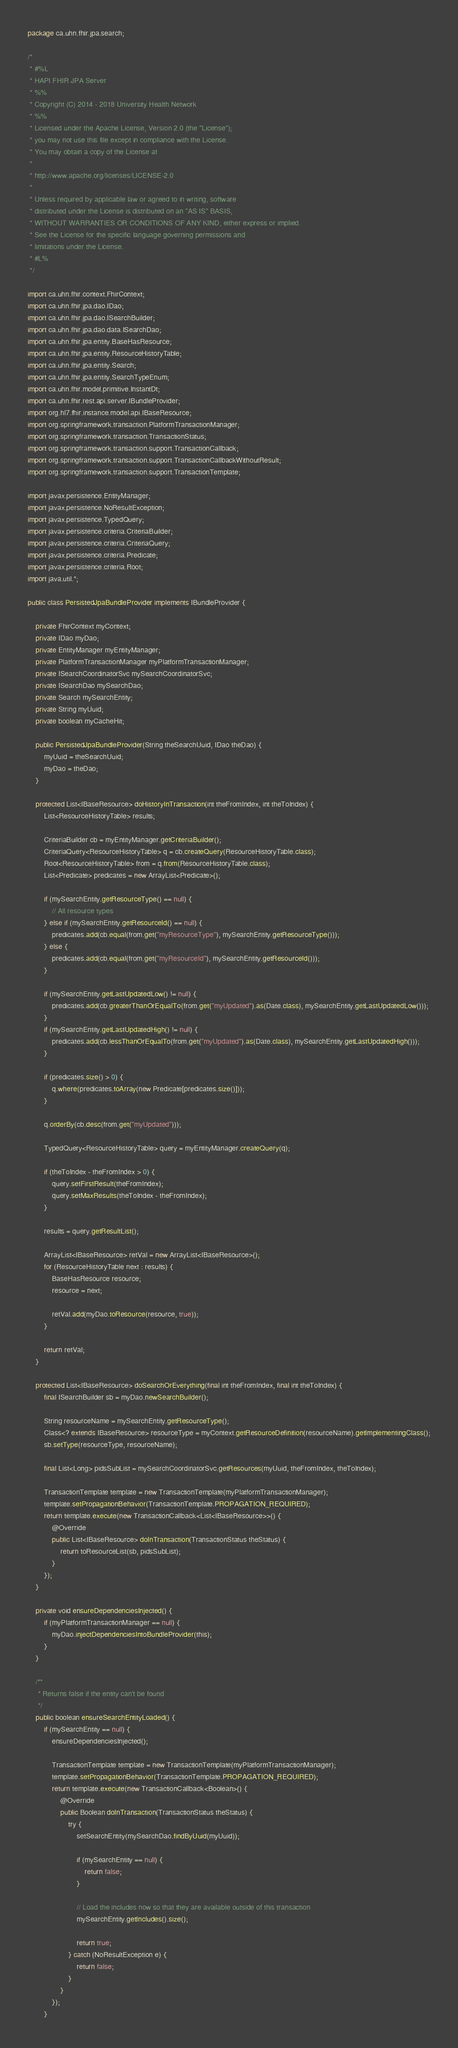Convert code to text. <code><loc_0><loc_0><loc_500><loc_500><_Java_>package ca.uhn.fhir.jpa.search;

/*
 * #%L
 * HAPI FHIR JPA Server
 * %%
 * Copyright (C) 2014 - 2018 University Health Network
 * %%
 * Licensed under the Apache License, Version 2.0 (the "License");
 * you may not use this file except in compliance with the License.
 * You may obtain a copy of the License at
 * 
 * http://www.apache.org/licenses/LICENSE-2.0
 * 
 * Unless required by applicable law or agreed to in writing, software
 * distributed under the License is distributed on an "AS IS" BASIS,
 * WITHOUT WARRANTIES OR CONDITIONS OF ANY KIND, either express or implied.
 * See the License for the specific language governing permissions and
 * limitations under the License.
 * #L%
 */

import ca.uhn.fhir.context.FhirContext;
import ca.uhn.fhir.jpa.dao.IDao;
import ca.uhn.fhir.jpa.dao.ISearchBuilder;
import ca.uhn.fhir.jpa.dao.data.ISearchDao;
import ca.uhn.fhir.jpa.entity.BaseHasResource;
import ca.uhn.fhir.jpa.entity.ResourceHistoryTable;
import ca.uhn.fhir.jpa.entity.Search;
import ca.uhn.fhir.jpa.entity.SearchTypeEnum;
import ca.uhn.fhir.model.primitive.InstantDt;
import ca.uhn.fhir.rest.api.server.IBundleProvider;
import org.hl7.fhir.instance.model.api.IBaseResource;
import org.springframework.transaction.PlatformTransactionManager;
import org.springframework.transaction.TransactionStatus;
import org.springframework.transaction.support.TransactionCallback;
import org.springframework.transaction.support.TransactionCallbackWithoutResult;
import org.springframework.transaction.support.TransactionTemplate;

import javax.persistence.EntityManager;
import javax.persistence.NoResultException;
import javax.persistence.TypedQuery;
import javax.persistence.criteria.CriteriaBuilder;
import javax.persistence.criteria.CriteriaQuery;
import javax.persistence.criteria.Predicate;
import javax.persistence.criteria.Root;
import java.util.*;

public class PersistedJpaBundleProvider implements IBundleProvider {

	private FhirContext myContext;
	private IDao myDao;
	private EntityManager myEntityManager;
	private PlatformTransactionManager myPlatformTransactionManager;
	private ISearchCoordinatorSvc mySearchCoordinatorSvc;
	private ISearchDao mySearchDao;
	private Search mySearchEntity;
	private String myUuid;
	private boolean myCacheHit;

	public PersistedJpaBundleProvider(String theSearchUuid, IDao theDao) {
		myUuid = theSearchUuid;
		myDao = theDao;
	}

	protected List<IBaseResource> doHistoryInTransaction(int theFromIndex, int theToIndex) {
		List<ResourceHistoryTable> results;

		CriteriaBuilder cb = myEntityManager.getCriteriaBuilder();
		CriteriaQuery<ResourceHistoryTable> q = cb.createQuery(ResourceHistoryTable.class);
		Root<ResourceHistoryTable> from = q.from(ResourceHistoryTable.class);
		List<Predicate> predicates = new ArrayList<Predicate>();

		if (mySearchEntity.getResourceType() == null) {
			// All resource types
		} else if (mySearchEntity.getResourceId() == null) {
			predicates.add(cb.equal(from.get("myResourceType"), mySearchEntity.getResourceType()));
		} else {
			predicates.add(cb.equal(from.get("myResourceId"), mySearchEntity.getResourceId()));
		}

		if (mySearchEntity.getLastUpdatedLow() != null) {
			predicates.add(cb.greaterThanOrEqualTo(from.get("myUpdated").as(Date.class), mySearchEntity.getLastUpdatedLow()));
		}
		if (mySearchEntity.getLastUpdatedHigh() != null) {
			predicates.add(cb.lessThanOrEqualTo(from.get("myUpdated").as(Date.class), mySearchEntity.getLastUpdatedHigh()));
		}

		if (predicates.size() > 0) {
			q.where(predicates.toArray(new Predicate[predicates.size()]));
		}

		q.orderBy(cb.desc(from.get("myUpdated")));

		TypedQuery<ResourceHistoryTable> query = myEntityManager.createQuery(q);

		if (theToIndex - theFromIndex > 0) {
			query.setFirstResult(theFromIndex);
			query.setMaxResults(theToIndex - theFromIndex);
		}

		results = query.getResultList();

		ArrayList<IBaseResource> retVal = new ArrayList<IBaseResource>();
		for (ResourceHistoryTable next : results) {
			BaseHasResource resource;
			resource = next;

			retVal.add(myDao.toResource(resource, true));
		}

		return retVal;
	}

	protected List<IBaseResource> doSearchOrEverything(final int theFromIndex, final int theToIndex) {
		final ISearchBuilder sb = myDao.newSearchBuilder();

		String resourceName = mySearchEntity.getResourceType();
		Class<? extends IBaseResource> resourceType = myContext.getResourceDefinition(resourceName).getImplementingClass();
		sb.setType(resourceType, resourceName);

		final List<Long> pidsSubList = mySearchCoordinatorSvc.getResources(myUuid, theFromIndex, theToIndex);

		TransactionTemplate template = new TransactionTemplate(myPlatformTransactionManager);
		template.setPropagationBehavior(TransactionTemplate.PROPAGATION_REQUIRED);
		return template.execute(new TransactionCallback<List<IBaseResource>>() {
			@Override
			public List<IBaseResource> doInTransaction(TransactionStatus theStatus) {
				return toResourceList(sb, pidsSubList);
			}
		});
	}

	private void ensureDependenciesInjected() {
		if (myPlatformTransactionManager == null) {
			myDao.injectDependenciesIntoBundleProvider(this);
		}
	}

	/**
	 * Returns false if the entity can't be found
	 */
	public boolean ensureSearchEntityLoaded() {
		if (mySearchEntity == null) {
			ensureDependenciesInjected();

			TransactionTemplate template = new TransactionTemplate(myPlatformTransactionManager);
			template.setPropagationBehavior(TransactionTemplate.PROPAGATION_REQUIRED);
			return template.execute(new TransactionCallback<Boolean>() {
				@Override
				public Boolean doInTransaction(TransactionStatus theStatus) {
					try {
						setSearchEntity(mySearchDao.findByUuid(myUuid));

						if (mySearchEntity == null) {
							return false;
						}

						// Load the includes now so that they are available outside of this transaction
						mySearchEntity.getIncludes().size();

						return true;
					} catch (NoResultException e) {
						return false;
					}
				}
			});
		}</code> 